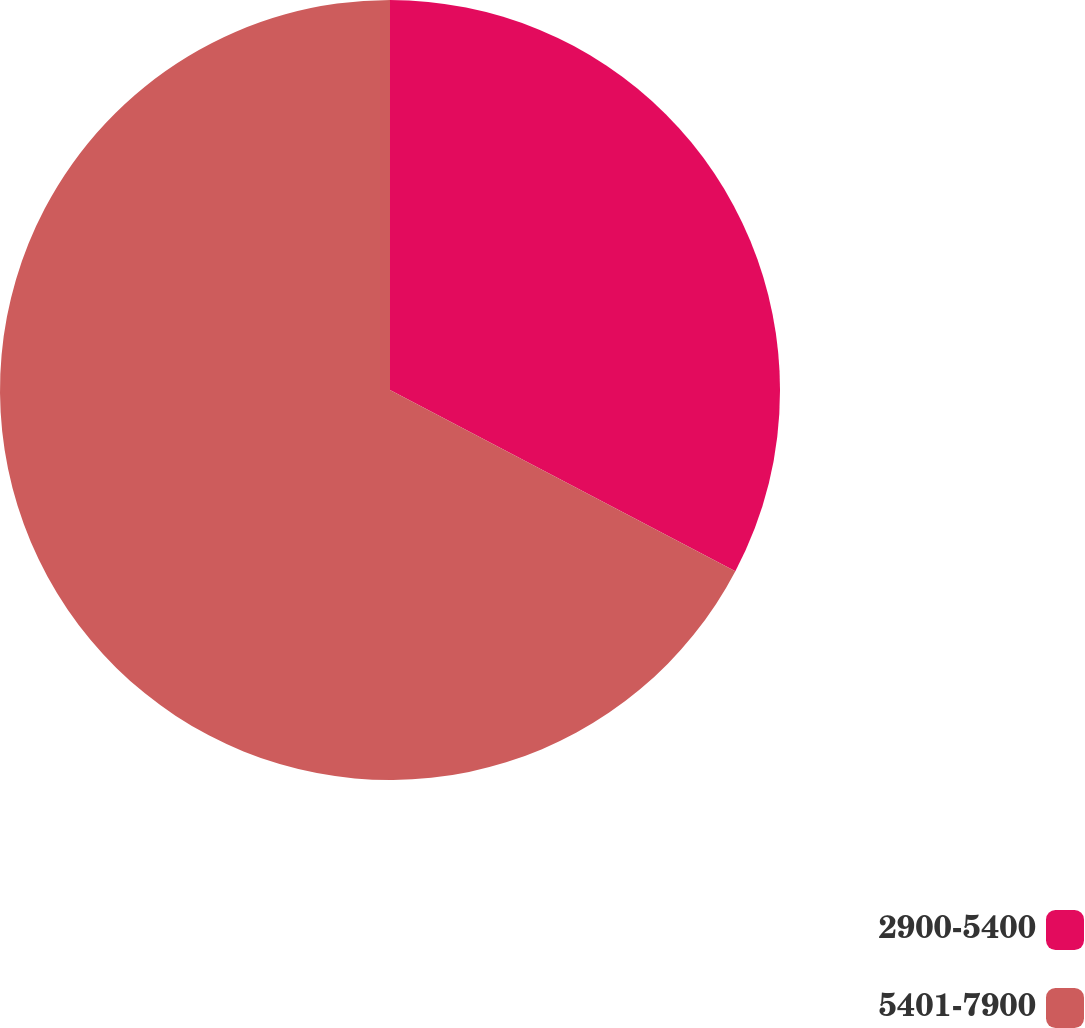<chart> <loc_0><loc_0><loc_500><loc_500><pie_chart><fcel>2900-5400<fcel>5401-7900<nl><fcel>32.69%<fcel>67.31%<nl></chart> 